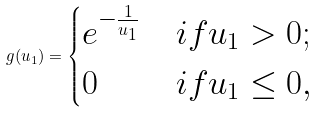Convert formula to latex. <formula><loc_0><loc_0><loc_500><loc_500>g ( u _ { 1 } ) = \begin{cases} e ^ { - \frac { 1 } { u _ { 1 } } } & i f u _ { 1 } > 0 ; \\ 0 & i f u _ { 1 } \leq 0 , \end{cases}</formula> 